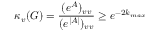Convert formula to latex. <formula><loc_0><loc_0><loc_500><loc_500>\kappa _ { v } ( G ) = \frac { ( e ^ { A } ) _ { v v } } { ( e ^ { | A | } ) _ { v v } } \geq e ^ { - 2 k _ { \max } }</formula> 